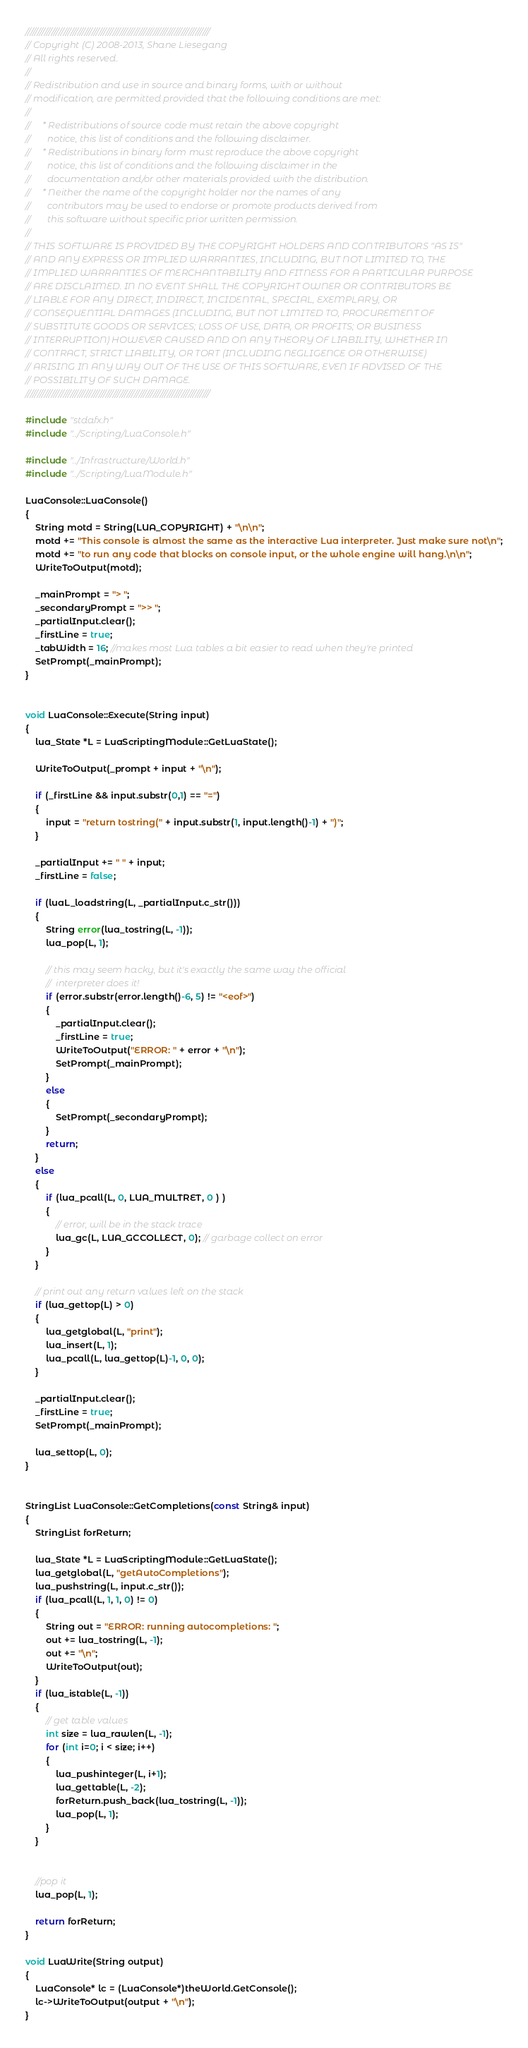<code> <loc_0><loc_0><loc_500><loc_500><_C++_>//////////////////////////////////////////////////////////////////////////////
// Copyright (C) 2008-2013, Shane Liesegang
// All rights reserved.
// 
// Redistribution and use in source and binary forms, with or without 
// modification, are permitted provided that the following conditions are met:
// 
//     * Redistributions of source code must retain the above copyright 
//       notice, this list of conditions and the following disclaimer.
//     * Redistributions in binary form must reproduce the above copyright 
//       notice, this list of conditions and the following disclaimer in the 
//       documentation and/or other materials provided with the distribution.
//     * Neither the name of the copyright holder nor the names of any 
//       contributors may be used to endorse or promote products derived from 
//       this software without specific prior written permission.
// 
// THIS SOFTWARE IS PROVIDED BY THE COPYRIGHT HOLDERS AND CONTRIBUTORS "AS IS" 
// AND ANY EXPRESS OR IMPLIED WARRANTIES, INCLUDING, BUT NOT LIMITED TO, THE 
// IMPLIED WARRANTIES OF MERCHANTABILITY AND FITNESS FOR A PARTICULAR PURPOSE 
// ARE DISCLAIMED. IN NO EVENT SHALL THE COPYRIGHT OWNER OR CONTRIBUTORS BE 
// LIABLE FOR ANY DIRECT, INDIRECT, INCIDENTAL, SPECIAL, EXEMPLARY, OR 
// CONSEQUENTIAL DAMAGES (INCLUDING, BUT NOT LIMITED TO, PROCUREMENT OF 
// SUBSTITUTE GOODS OR SERVICES; LOSS OF USE, DATA, OR PROFITS; OR BUSINESS 
// INTERRUPTION) HOWEVER CAUSED AND ON ANY THEORY OF LIABILITY, WHETHER IN 
// CONTRACT, STRICT LIABILITY, OR TORT (INCLUDING NEGLIGENCE OR OTHERWISE) 
// ARISING IN ANY WAY OUT OF THE USE OF THIS SOFTWARE, EVEN IF ADVISED OF THE 
// POSSIBILITY OF SUCH DAMAGE.
//////////////////////////////////////////////////////////////////////////////

#include "stdafx.h"
#include "../Scripting/LuaConsole.h"

#include "../Infrastructure/World.h"
#include "../Scripting/LuaModule.h"

LuaConsole::LuaConsole()
{
	String motd = String(LUA_COPYRIGHT) + "\n\n";
	motd += "This console is almost the same as the interactive Lua interpreter. Just make sure not\n";
	motd += "to run any code that blocks on console input, or the whole engine will hang.\n\n";
	WriteToOutput(motd);
	
	_mainPrompt = "> ";
	_secondaryPrompt = ">> ";
	_partialInput.clear();
	_firstLine = true;
	_tabWidth = 16; //makes most Lua tables a bit easier to read when they're printed
	SetPrompt(_mainPrompt);
}


void LuaConsole::Execute(String input)
{
	lua_State *L = LuaScriptingModule::GetLuaState();
	
	WriteToOutput(_prompt + input + "\n");
	
	if (_firstLine && input.substr(0,1) == "=")
	{
		input = "return tostring(" + input.substr(1, input.length()-1) + ")";
	}
	
	_partialInput += " " + input;
	_firstLine = false;
	
	if (luaL_loadstring(L, _partialInput.c_str()))
	{
		String error(lua_tostring(L, -1));
		lua_pop(L, 1);
		
		// this may seem hacky, but it's exactly the same way the official
		//  interpreter does it!
		if (error.substr(error.length()-6, 5) != "<eof>")
		{
			_partialInput.clear();
			_firstLine = true;
			WriteToOutput("ERROR: " + error + "\n");
			SetPrompt(_mainPrompt);
		}
		else
		{
			SetPrompt(_secondaryPrompt); 
		}
		return;
	}
	else
	{
		if (lua_pcall(L, 0, LUA_MULTRET, 0 ) )
		{
			// error, will be in the stack trace
			lua_gc(L, LUA_GCCOLLECT, 0); // garbage collect on error
		}
	}
	
	// print out any return values left on the stack
	if (lua_gettop(L) > 0)
	{
		lua_getglobal(L, "print");
		lua_insert(L, 1);
		lua_pcall(L, lua_gettop(L)-1, 0, 0);
	}
	
	_partialInput.clear();
	_firstLine = true;
	SetPrompt(_mainPrompt);
	
	lua_settop(L, 0);
}


StringList LuaConsole::GetCompletions(const String& input)
{
	StringList forReturn;
	
	lua_State *L = LuaScriptingModule::GetLuaState();
	lua_getglobal(L, "getAutoCompletions");
	lua_pushstring(L, input.c_str());
	if (lua_pcall(L, 1, 1, 0) != 0)
	{
		String out = "ERROR: running autocompletions: ";
		out += lua_tostring(L, -1);
		out += "\n";
		WriteToOutput(out);
	}
	if (lua_istable(L, -1))
	{
		// get table values
		int size = lua_rawlen(L, -1);
		for (int i=0; i < size; i++)
		{
			lua_pushinteger(L, i+1);
			lua_gettable(L, -2);
			forReturn.push_back(lua_tostring(L, -1));
			lua_pop(L, 1);
		}
	}

	
	//pop it
	lua_pop(L, 1);
	
	return forReturn;
}

void LuaWrite(String output)
{
	LuaConsole* lc = (LuaConsole*)theWorld.GetConsole();
	lc->WriteToOutput(output + "\n");
}
</code> 